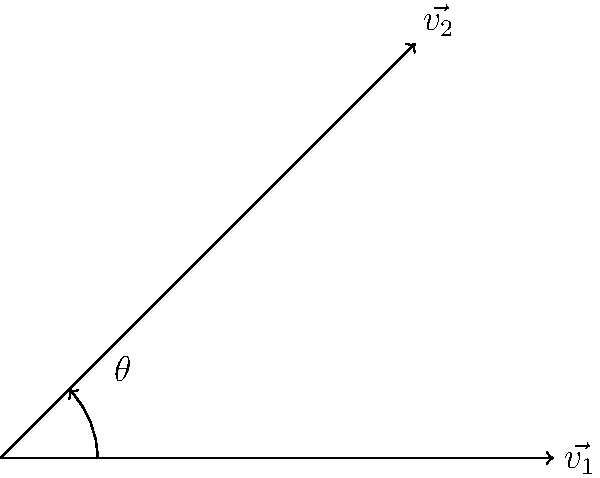Given two wind vectors $\vec{v_1}$ and $\vec{v_2}$ as shown in the diagram, where $\vec{v_1} = 4\hat{i}$ and $\vec{v_2} = 3\hat{i} + 3\hat{j}$, calculate the angle $\theta$ between them. To find the angle between two vectors, we can use the dot product formula:

$$\cos \theta = \frac{\vec{v_1} \cdot \vec{v_2}}{|\vec{v_1}||\vec{v_2}|}$$

Step 1: Calculate the dot product $\vec{v_1} \cdot \vec{v_2}$
$$\vec{v_1} \cdot \vec{v_2} = (4)(3) + (0)(3) = 12$$

Step 2: Calculate the magnitudes of the vectors
$$|\vec{v_1}| = \sqrt{4^2 + 0^2} = 4$$
$$|\vec{v_2}| = \sqrt{3^2 + 3^2} = 3\sqrt{2}$$

Step 3: Substitute into the dot product formula
$$\cos \theta = \frac{12}{4(3\sqrt{2})} = \frac{\sqrt{2}}{2}$$

Step 4: Take the inverse cosine (arccos) of both sides
$$\theta = \arccos(\frac{\sqrt{2}}{2})$$

Step 5: Calculate the final result
$$\theta \approx 45^\circ$$
Answer: $45^\circ$ 